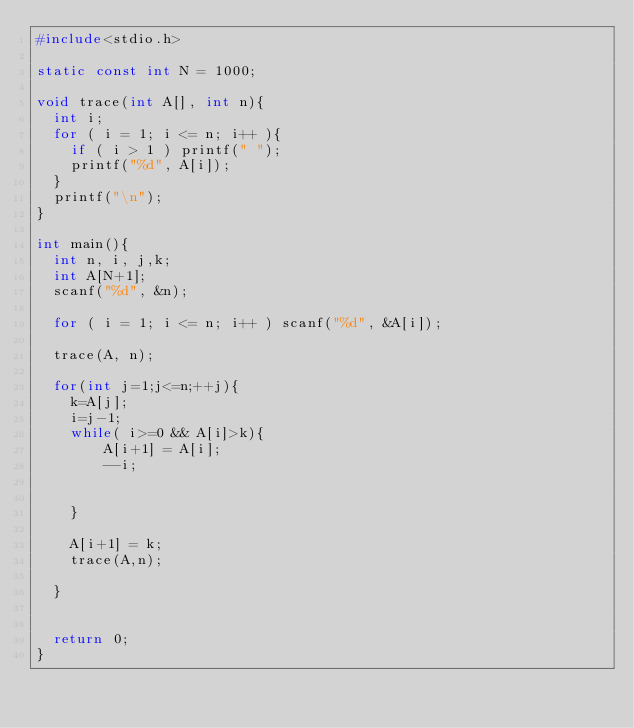Convert code to text. <code><loc_0><loc_0><loc_500><loc_500><_C++_>#include<stdio.h>

static const int N = 1000;

void trace(int A[], int n){
  int i;
  for ( i = 1; i <= n; i++ ){
    if ( i > 1 ) printf(" ");
    printf("%d", A[i]);
  }
  printf("\n");
}

int main(){
  int n, i, j,k;
  int A[N+1];
  scanf("%d", &n);

  for ( i = 1; i <= n; i++ ) scanf("%d", &A[i]);
  
  trace(A, n);
  
  for(int j=1;j<=n;++j){
  	k=A[j];
  	i=j-1;
	while( i>=0 && A[i]>k){
		A[i+1] = A[i];
		--i;
		
		
	}
	
	A[i+1] = k;
	trace(A,n);
	
  }
  

  return 0;
}</code> 